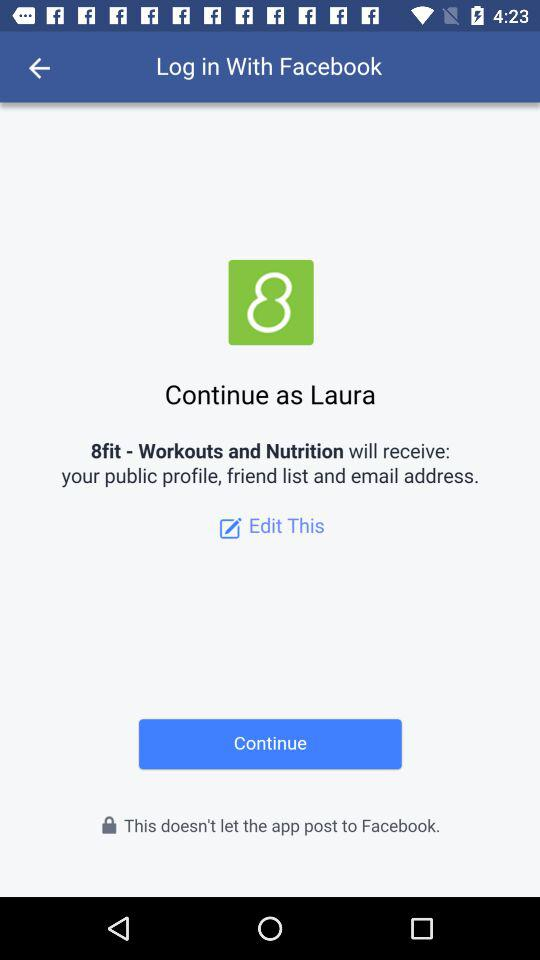What is the name of the user? The name of the user is Laura. 